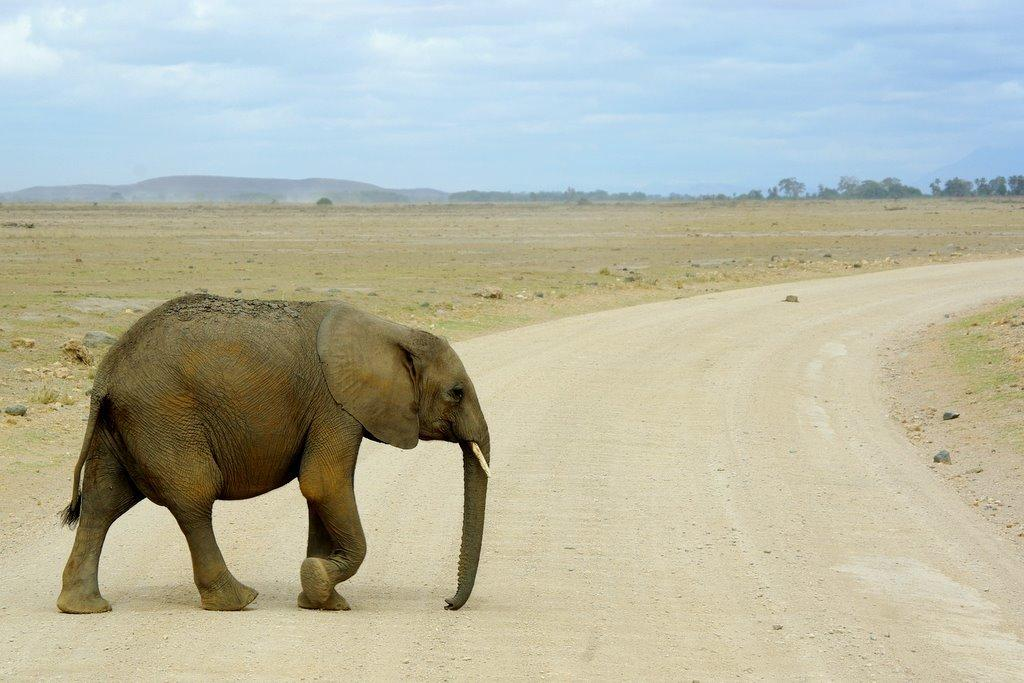What animal is present in the image? There is an elephant in the image. What is the elephant doing in the image? The elephant is walking on the road surface. What can be seen in the distance in the image? There are mountains and trees in the background of the image. Where is the faucet located in the image? There is no faucet present in the image. What type of seat is the elephant sitting on in the image? The elephant is not sitting on a seat in the image; it is walking on the road surface. 